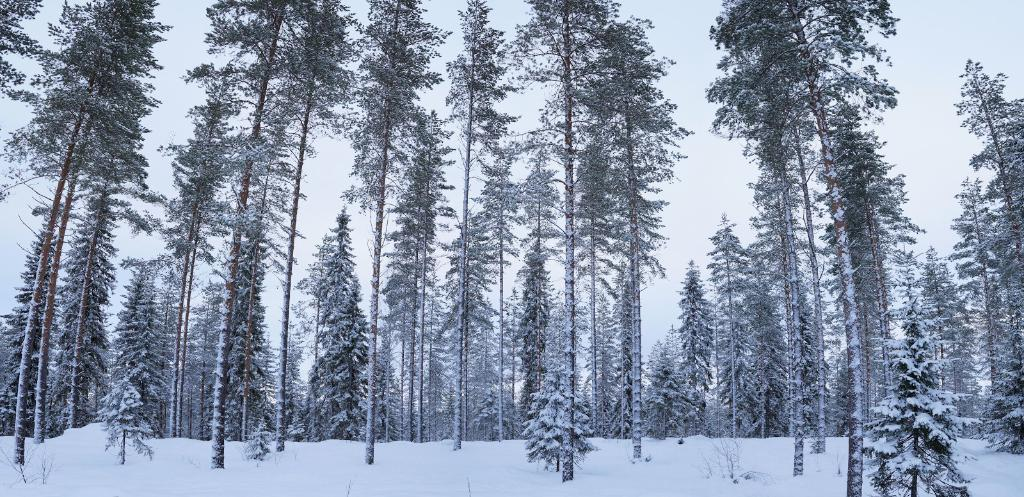What type of vegetation can be seen in the image? There are trees in the image. What is visible in the background of the image? There is a sky visible in the background of the image. How many houses can be seen in the image? There are no houses visible in the image; it only features trees and a sky. What type of flowers are growing near the trees in the image? There are no flowers present in the image; it only features trees and a sky. 